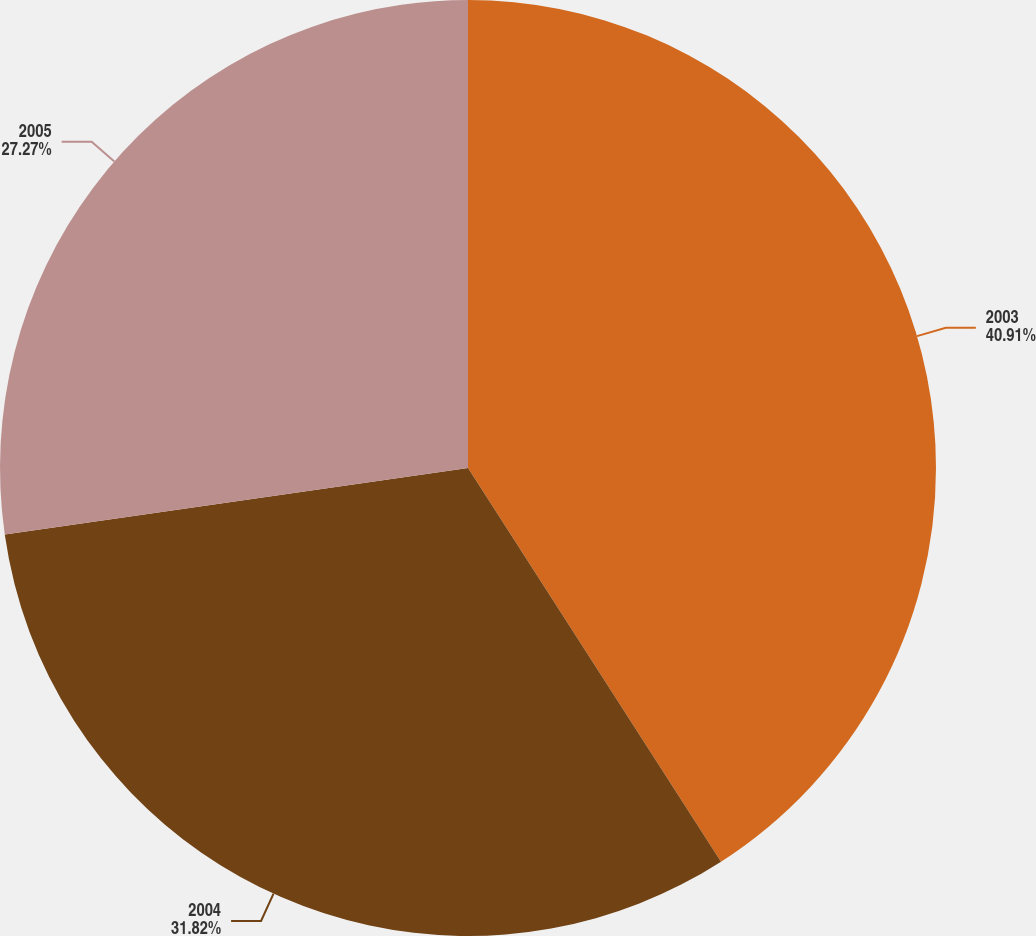<chart> <loc_0><loc_0><loc_500><loc_500><pie_chart><fcel>2003<fcel>2004<fcel>2005<nl><fcel>40.91%<fcel>31.82%<fcel>27.27%<nl></chart> 